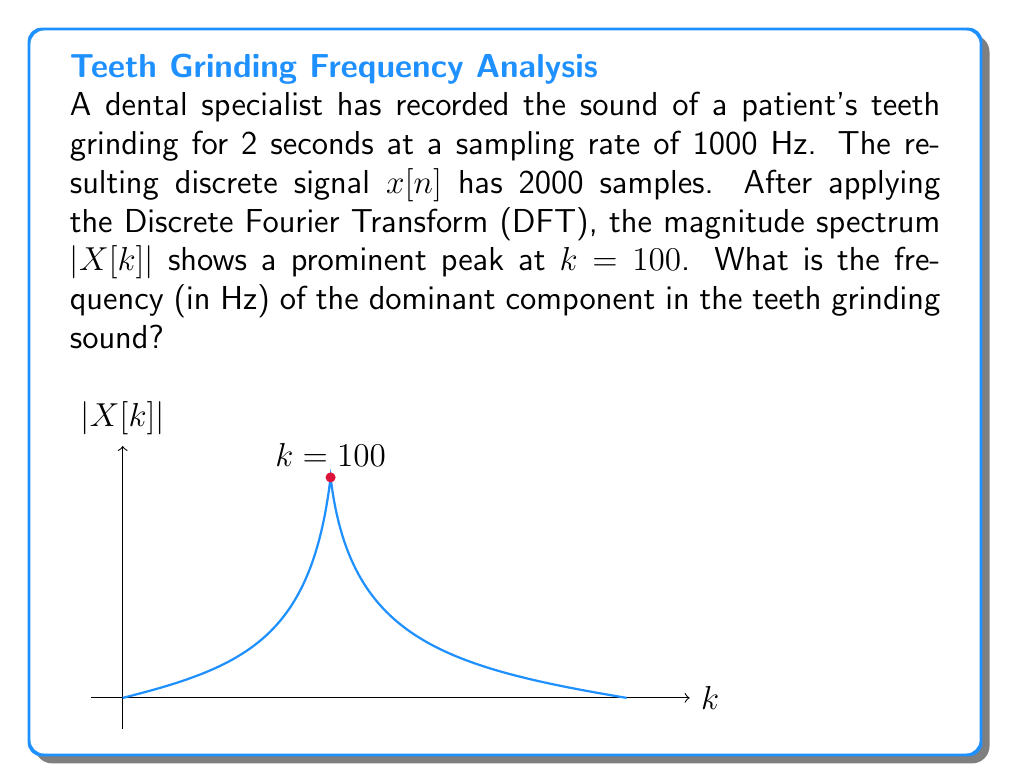Provide a solution to this math problem. To solve this problem, we need to use the relationship between the DFT index $k$ and the actual frequency $f$ in Hz. Here's the step-by-step solution:

1) In the DFT, the frequency resolution $\Delta f$ is given by:

   $$\Delta f = \frac{f_s}{N}$$

   where $f_s$ is the sampling frequency and $N$ is the total number of samples.

2) We're given:
   - Sampling rate $f_s = 1000$ Hz
   - Number of samples $N = 2000$

3) Calculate the frequency resolution:

   $$\Delta f = \frac{1000 \text{ Hz}}{2000} = 0.5 \text{ Hz}$$

4) The frequency corresponding to a given $k$ index is:

   $$f = k \cdot \Delta f$$

5) We're told that the prominent peak is at $k = 100$. So, the frequency of this peak is:

   $$f = 100 \cdot 0.5 \text{ Hz} = 50 \text{ Hz}$$

Therefore, the dominant frequency component in the teeth grinding sound is 50 Hz.
Answer: 50 Hz 